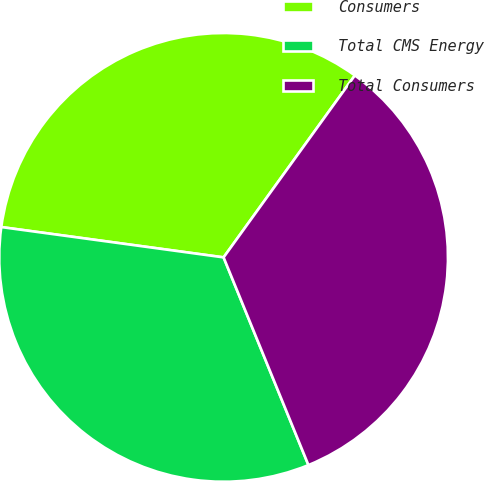Convert chart to OTSL. <chart><loc_0><loc_0><loc_500><loc_500><pie_chart><fcel>Consumers<fcel>Total CMS Energy<fcel>Total Consumers<nl><fcel>32.79%<fcel>33.33%<fcel>33.88%<nl></chart> 